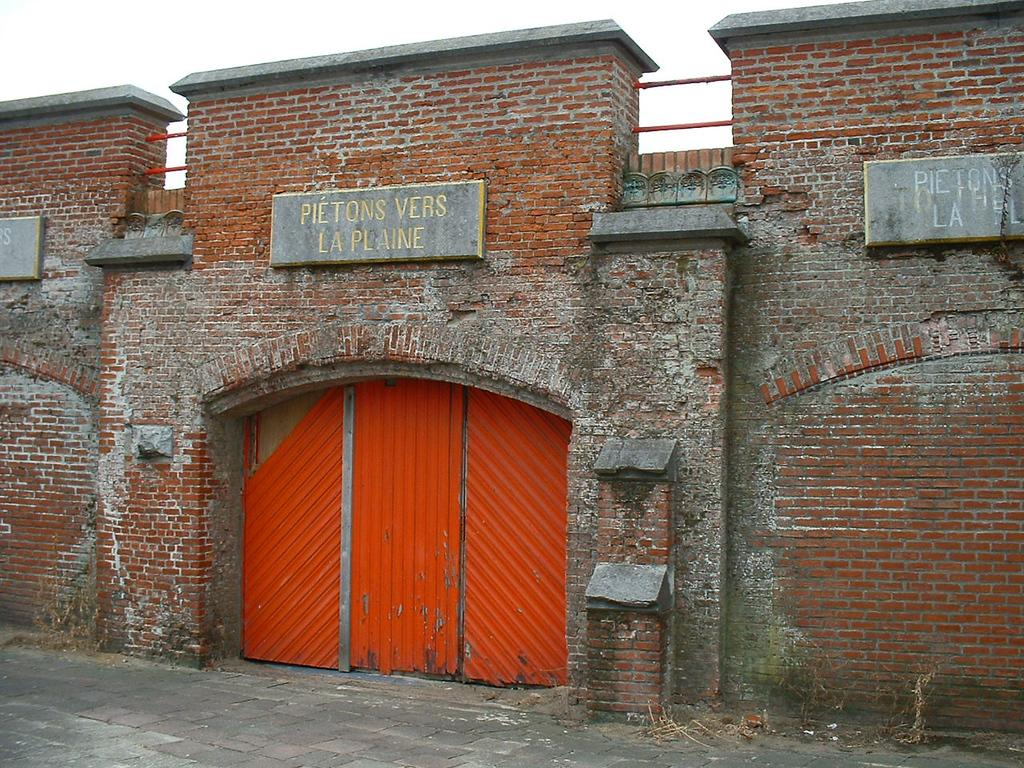What type of structure can be seen in the image? There is a wall in the image. What is located near the wall? There is a gate in the image. What color is the gate? The gate is red. What is at the bottom of the image? There is a road at the bottom of the image. What type of signs are present in the image? There are name boards in the image. What is visible at the top of the image? The sky is visible at the top of the image. What type of rhythm can be heard coming from the stage in the image? There is no stage present in the image, so it's not possible to determine what type of rhythm might be heard. 